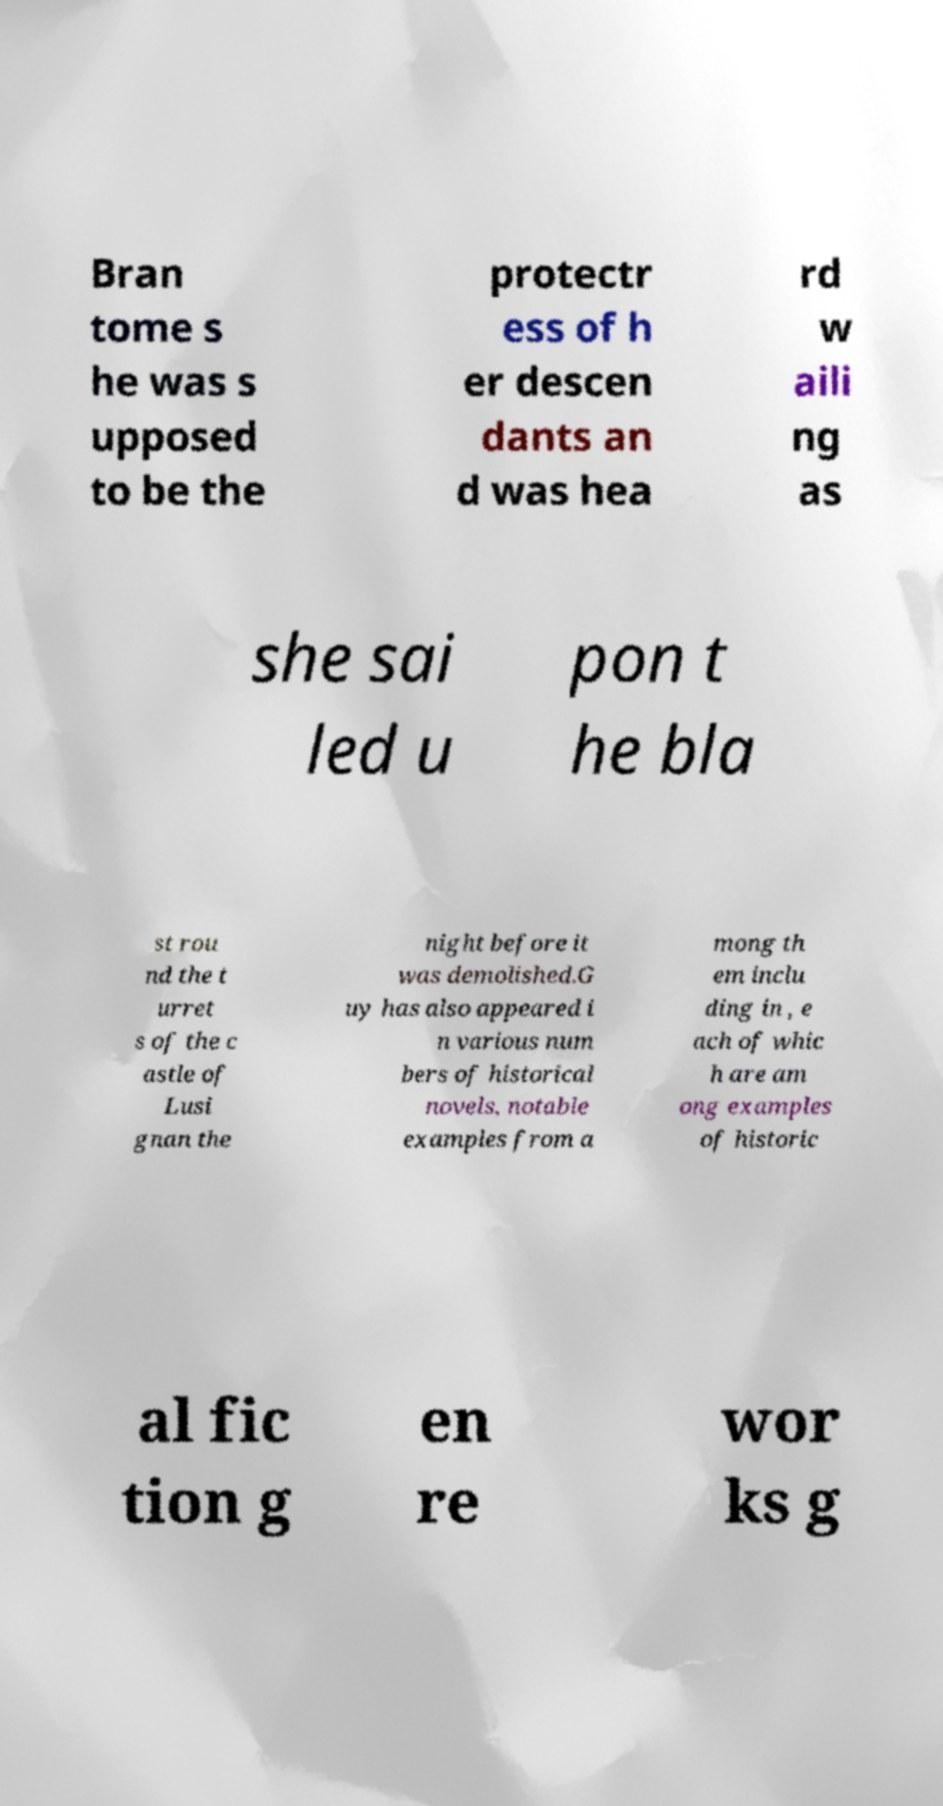What messages or text are displayed in this image? I need them in a readable, typed format. Bran tome s he was s upposed to be the protectr ess of h er descen dants an d was hea rd w aili ng as she sai led u pon t he bla st rou nd the t urret s of the c astle of Lusi gnan the night before it was demolished.G uy has also appeared i n various num bers of historical novels, notable examples from a mong th em inclu ding in , e ach of whic h are am ong examples of historic al fic tion g en re wor ks g 